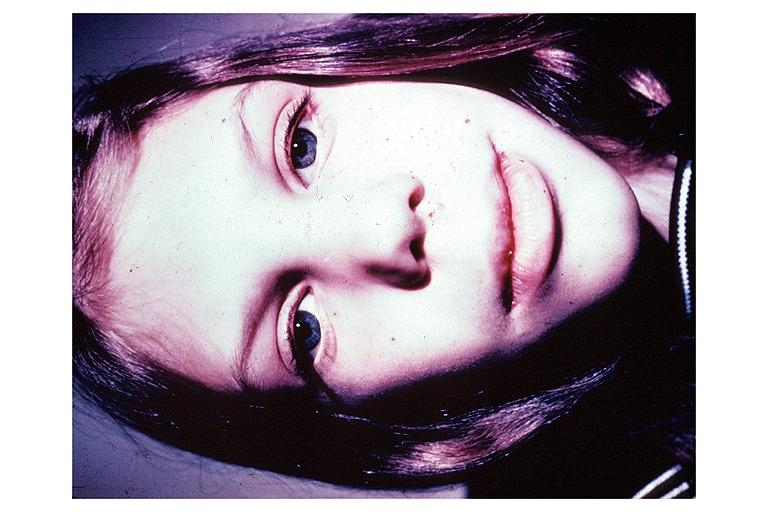does krukenberg tumor show multiple endocrine neoplasia type iib?
Answer the question using a single word or phrase. No 